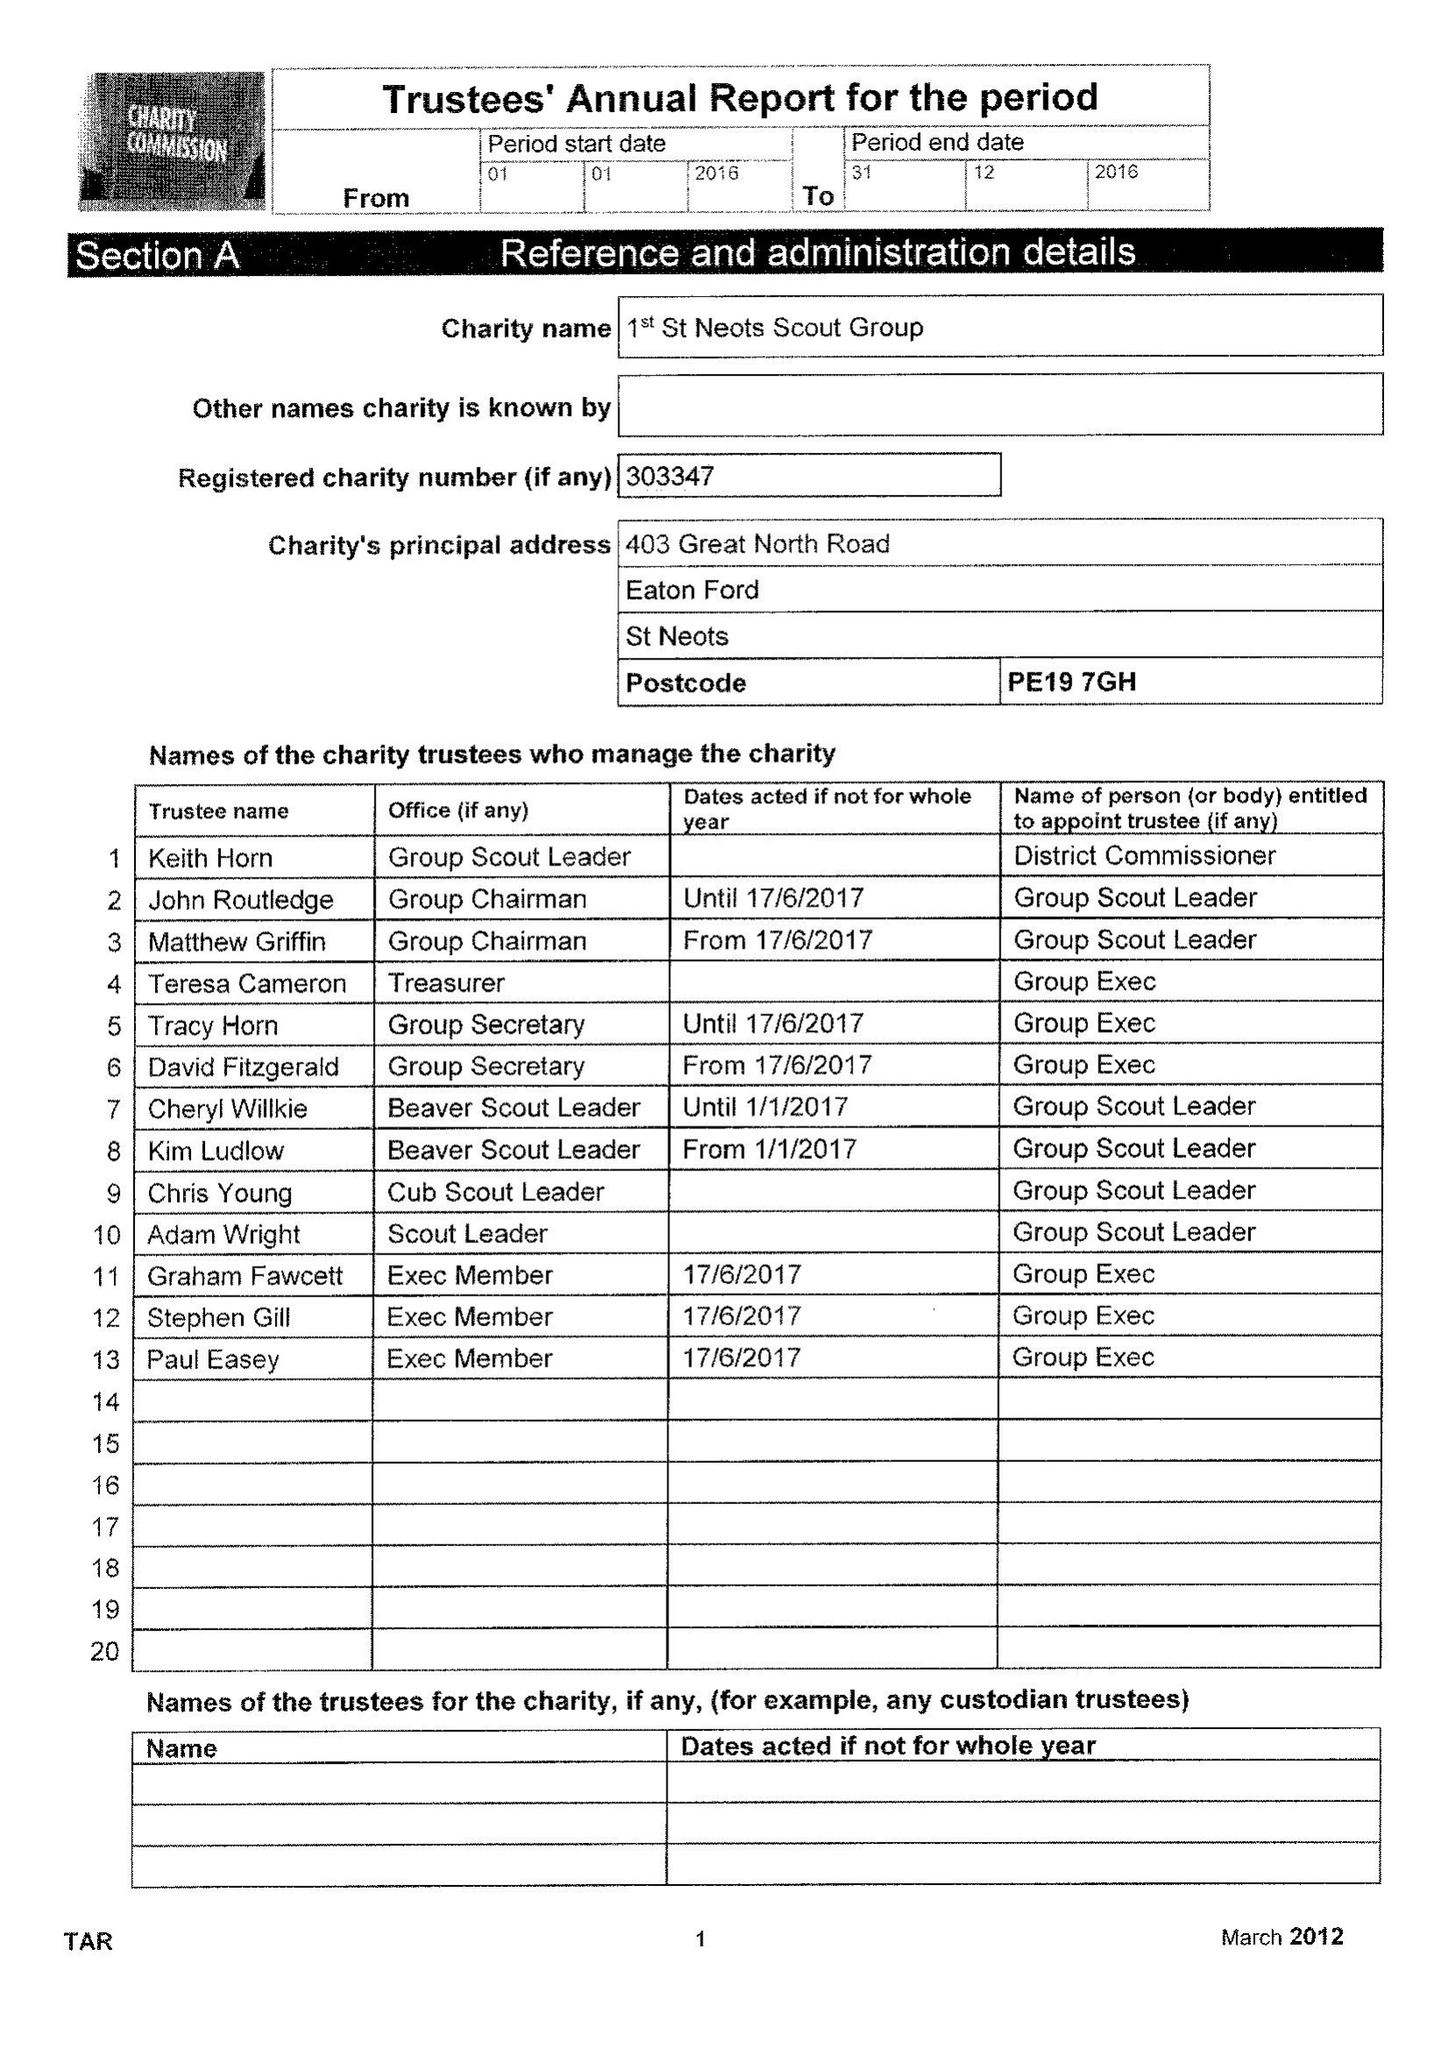What is the value for the charity_number?
Answer the question using a single word or phrase. 303347 